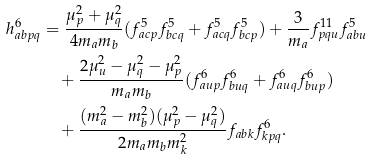Convert formula to latex. <formula><loc_0><loc_0><loc_500><loc_500>h ^ { 6 } _ { a b p q } & = \frac { \mu _ { p } ^ { 2 } + \mu _ { q } ^ { 2 } } { 4 m _ { a } m _ { b } } ( f ^ { 5 } _ { a c p } f ^ { 5 } _ { b c q } + f ^ { 5 } _ { a c q } f ^ { 5 } _ { b c p } ) + \frac { 3 } { m _ { a } } f ^ { 1 1 } _ { p q u } f ^ { 5 } _ { a b u } \\ & \quad + \frac { 2 \mu _ { u } ^ { 2 } - \mu _ { q } ^ { 2 } - \mu _ { p } ^ { 2 } } { m _ { a } m _ { b } } ( f ^ { 6 } _ { a u p } f ^ { 6 } _ { b u q } + f ^ { 6 } _ { a u q } f ^ { 6 } _ { b u p } ) \\ & \quad + \frac { ( m _ { a } ^ { 2 } - m _ { b } ^ { 2 } ) ( \mu _ { p } ^ { 2 } - \mu _ { q } ^ { 2 } ) } { 2 m _ { a } m _ { b } m _ { k } ^ { 2 } } f _ { a b k } f ^ { 6 } _ { k p q } .</formula> 